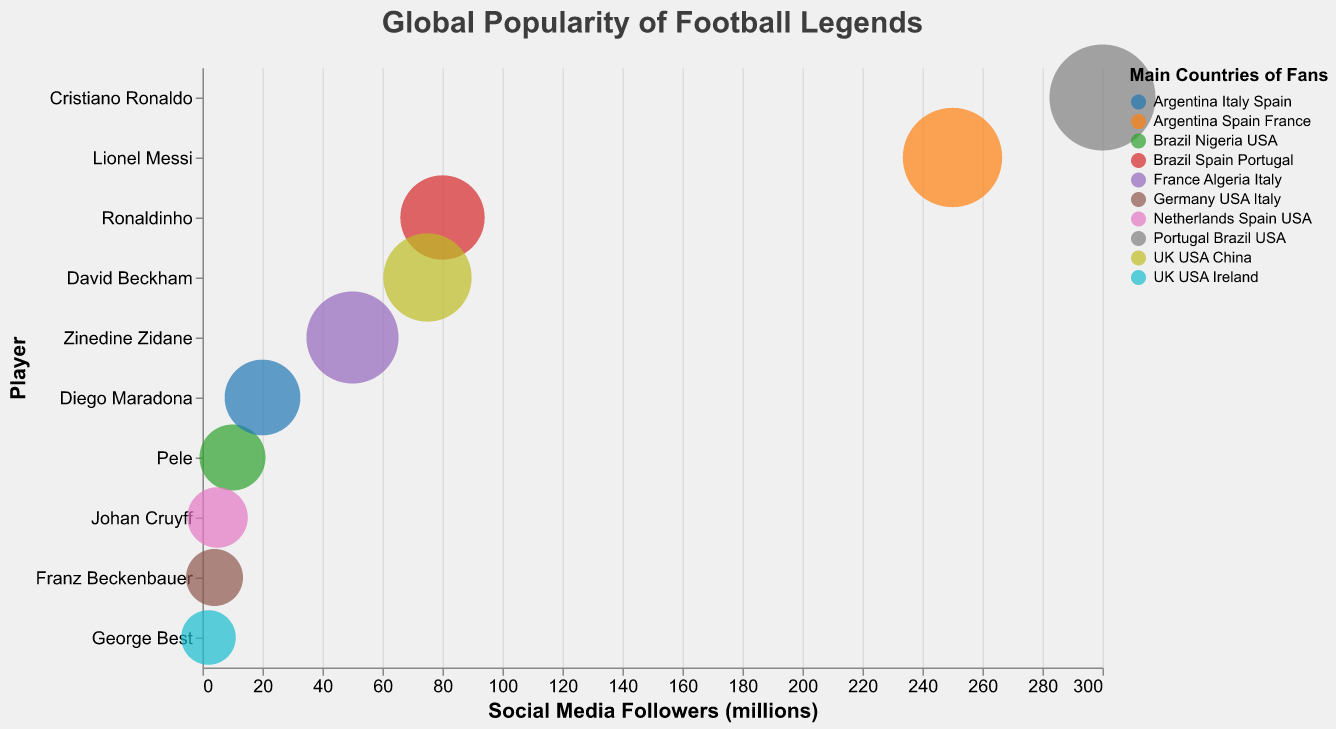What is the title of the chart? The title is displayed prominently at the top of the chart. From the given data, the title is "Global Popularity of Football Legends."
Answer: "Global Popularity of Football Legends" Which player has the most social media followers, and how many do they have? By referring to the x-axis and the tooltip information, Cristiano Ronaldo has the highest number of social media followers at 300 million.
Answer: Cristiano Ronaldo, 300 million Which players have the USA as one of their main countries of fans? By examining the "Main Countries of Fans" field for each player, we see that the players with the USA as one of their main countries are Cristiano Ronaldo, Pele, Franz Beckenbauer, David Beckham, George Best, and Johan Cruyff.
Answer: Cristiano Ronaldo, Pele, Franz Beckenbauer, David Beckham, George Best, Johan Cruyff What is the difference in social media followers between Lionel Messi and Diego Maradona? Lionel Messi has 250 million followers, and Diego Maradona has 20 million. The difference is 250 - 20 = 230 million.
Answer: 230 million Which player’s bubble size is the largest, and what does this size represent? The largest bubble size is 80, which belongs to Cristiano Ronaldo. This size represents the overall popularity metric assigned in the dataset.
Answer: Cristiano Ronaldo, 80 Compare the social media followers of Ronaldinho and David Beckham. Who has more and by how much? Ronaldinho has 80 million followers, and David Beckham has 75 million followers. Ronaldinho has 5 million more followers.
Answer: Ronaldinho, 5 million Which countries appear most frequently as the main countries of fans among all players? By inspecting the "Main Countries of Fans" for all players, the USA appears most frequently, being a main country for Cristiano Ronaldo, Pele, Franz Beckenbauer, David Beckham, George Best, and Johan Cruyff. It appears in 6 out of 10 players' lists.
Answer: USA What is the social media followers' range among the displayed football legends? The football legends' social media followers range from the lowest value of 2 million (George Best) to the highest of 300 million (Cristiano Ronaldo). The range is 300 - 2 = 298 million.
Answer: 298 million Which players have social media followers below 10 million, and in which countries do they have main fan bases? Players with fewer than 10 million followers are Johan Cruyff (5 million), Franz Beckenbauer (4 million), and George Best (2 million). Their main fan countries are Netherlands, Spain, USA (Johan Cruyff), Germany, USA, Italy (Franz Beckenbauer), and UK, USA, Ireland (George Best).
Answer: Johan Cruyff, Franz Beckenbauer, George Best What is the average number of social media followers across all players shown? Sum of all followers is 250 + 300 + 10 + 20 + 50 + 80 + 75 + 5 + 4 + 2 = 796 million. There are 10 players, so the average is 796 / 10 = 79.6 million.
Answer: 79.6 million 